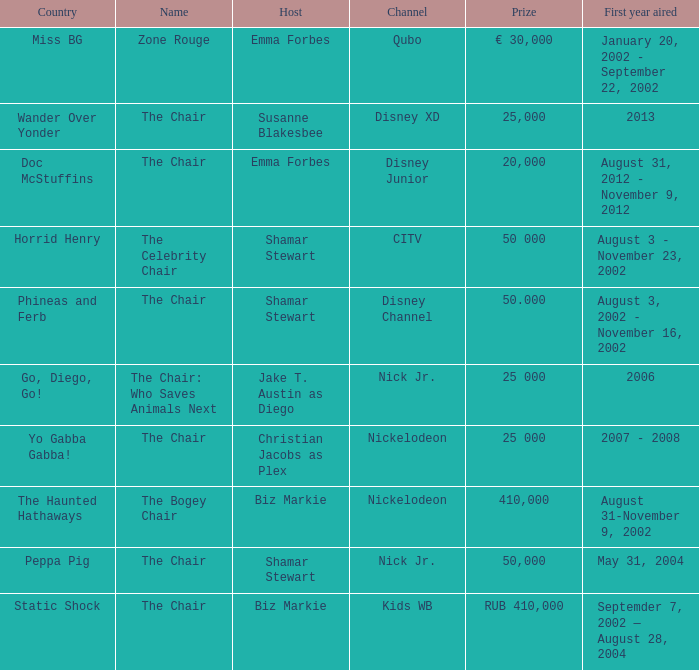What year did Zone Rouge first air? January 20, 2002 - September 22, 2002. Give me the full table as a dictionary. {'header': ['Country', 'Name', 'Host', 'Channel', 'Prize', 'First year aired'], 'rows': [['Miss BG', 'Zone Rouge', 'Emma Forbes', 'Qubo', '€ 30,000', 'January 20, 2002 - September 22, 2002'], ['Wander Over Yonder', 'The Chair', 'Susanne Blakesbee', 'Disney XD', '25,000', '2013'], ['Doc McStuffins', 'The Chair', 'Emma Forbes', 'Disney Junior', '20,000', 'August 31, 2012 - November 9, 2012'], ['Horrid Henry', 'The Celebrity Chair', 'Shamar Stewart', 'CITV', '50 000', 'August 3 - November 23, 2002'], ['Phineas and Ferb', 'The Chair', 'Shamar Stewart', 'Disney Channel', '50.000', 'August 3, 2002 - November 16, 2002'], ['Go, Diego, Go!', 'The Chair: Who Saves Animals Next', 'Jake T. Austin as Diego', 'Nick Jr.', '25 000', '2006'], ['Yo Gabba Gabba!', 'The Chair', 'Christian Jacobs as Plex', 'Nickelodeon', '25 000', '2007 - 2008'], ['The Haunted Hathaways', 'The Bogey Chair', 'Biz Markie', 'Nickelodeon', '410,000', 'August 31-November 9, 2002'], ['Peppa Pig', 'The Chair', 'Shamar Stewart', 'Nick Jr.', '50,000', 'May 31, 2004'], ['Static Shock', 'The Chair', 'Biz Markie', 'Kids WB', 'RUB 410,000', 'Septemder 7, 2002 — August 28, 2004']]} 